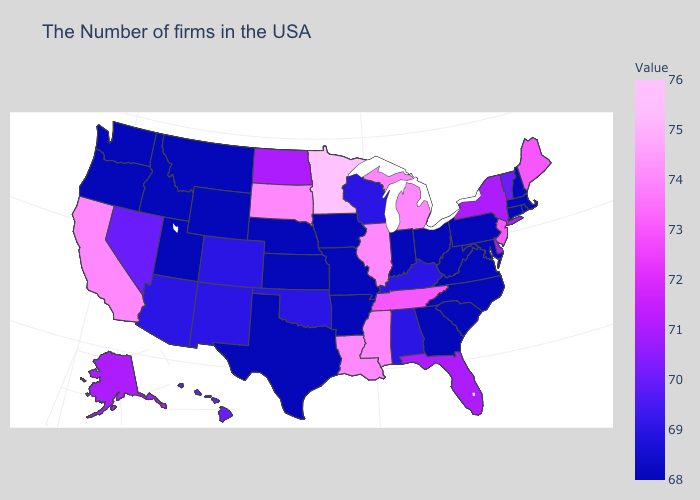Does Minnesota have the highest value in the USA?
Keep it brief. Yes. Does Ohio have the lowest value in the USA?
Give a very brief answer. Yes. Among the states that border Delaware , which have the lowest value?
Keep it brief. Maryland, Pennsylvania. Which states have the lowest value in the West?
Short answer required. Wyoming, Utah, Montana, Idaho, Washington, Oregon. Among the states that border Delaware , which have the lowest value?
Quick response, please. Maryland, Pennsylvania. Which states have the lowest value in the USA?
Answer briefly. Massachusetts, Rhode Island, New Hampshire, Connecticut, Maryland, Pennsylvania, Virginia, North Carolina, South Carolina, West Virginia, Ohio, Georgia, Indiana, Missouri, Arkansas, Iowa, Kansas, Nebraska, Texas, Wyoming, Utah, Montana, Idaho, Washington, Oregon. 